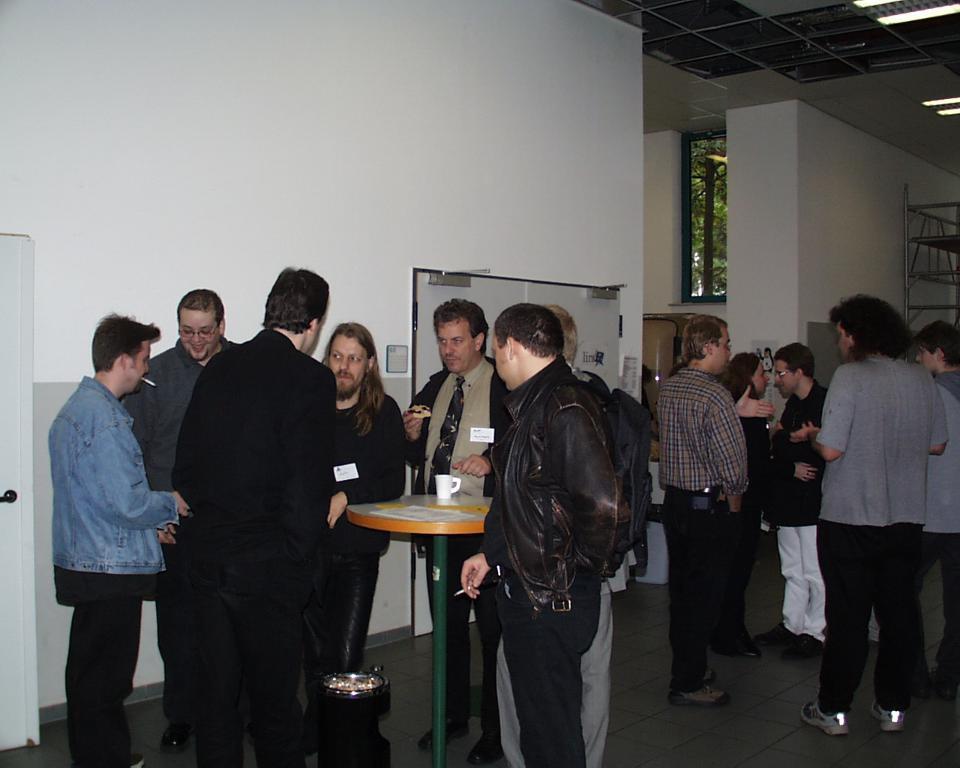Can you describe this image briefly? In this image there are people standing on a floor in the middle there is a table on that table there is a cup, under the table there is a dustbin, in the background there is a wall and lights. 